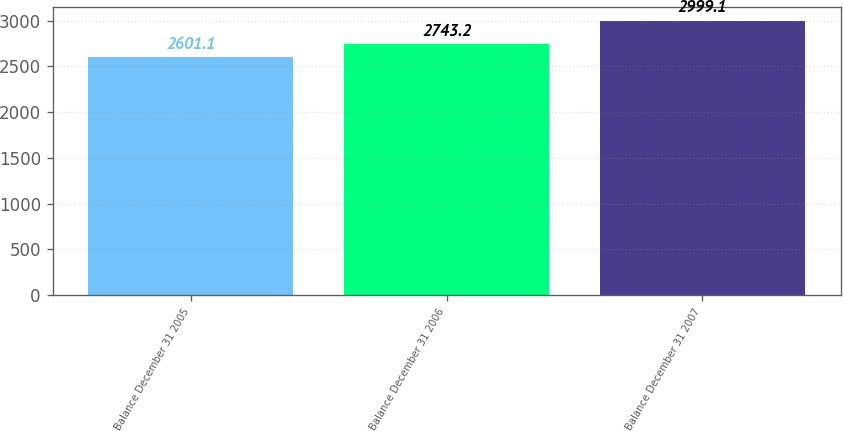Convert chart to OTSL. <chart><loc_0><loc_0><loc_500><loc_500><bar_chart><fcel>Balance December 31 2005<fcel>Balance December 31 2006<fcel>Balance December 31 2007<nl><fcel>2601.1<fcel>2743.2<fcel>2999.1<nl></chart> 